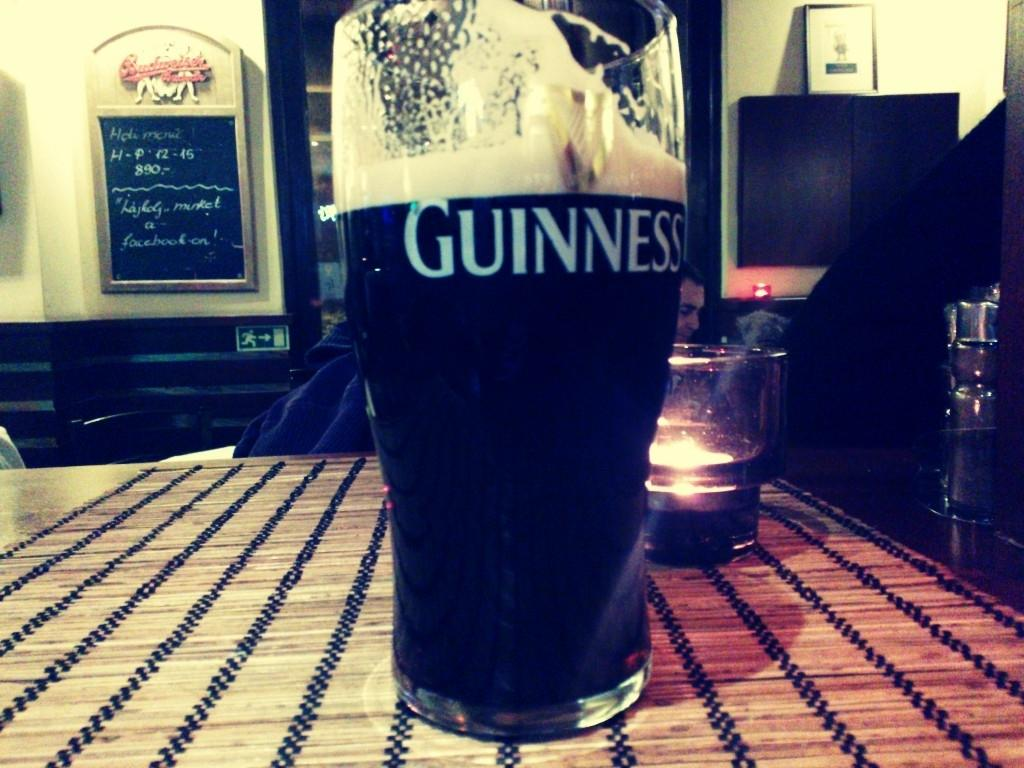What objects are on the table in the image? There are glasses on the table in the image. What can be seen on the board in the image? There is a board with text in the image. Where is the photo frame located in the image? The photo frame is on a cupboard in the image. How many legs does the dinosaur have in the image? There are no dinosaurs present in the image, so it is not possible to determine the number of legs they might have. 